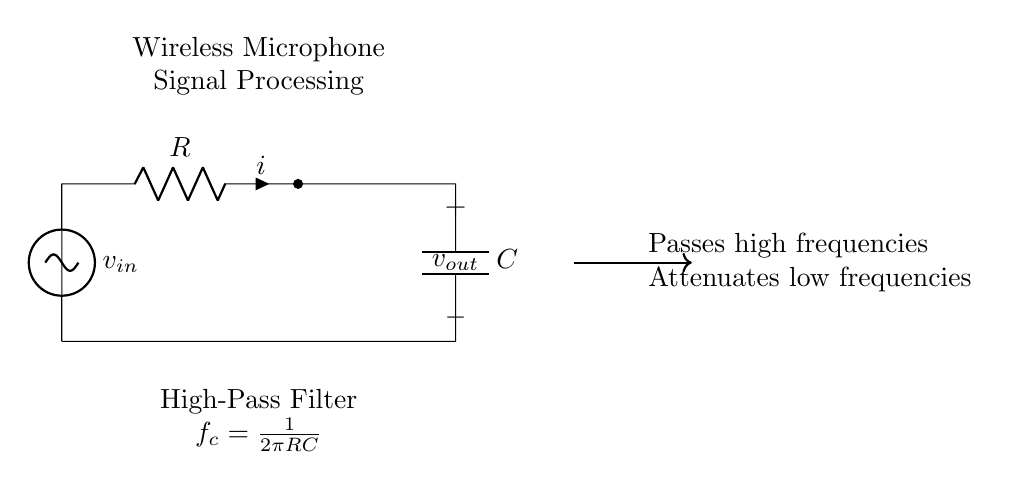What is the type of filter represented in this circuit? The circuit diagram depicts a high-pass filter, which is specifically engineered to allow high-frequency signals while blocking low-frequency signals. This is indicated by the components and the labeling in the diagram noting it as a high-pass filter.
Answer: high-pass filter What are the components used in the high-pass filter? The components in the circuit are a resistor and a capacitor. The resistor is denoted as "R," and the capacitor is denoted as "C." Their arrangement is characteristic of a high-pass filter.
Answer: resistor and capacitor What is the formula for the cutoff frequency? The cutoff frequency of the high-pass filter is calculated using the formula f_c = 1/(2πRC). This formula represents the frequency at which the output voltage falls to 70.7% of the input voltage.
Answer: 1/(2πRC) What does the high-pass filter do to low frequencies? This filter attenuates low frequencies, meaning it reduces their amplitude as they pass through the circuit. The diagram’s labeling indicates that it specifically targets low-frequency interference by minimizing its presence in the output.
Answer: attenuates What is the output voltage denoted as in the circuit? The output voltage is denoted as "v_out." In the circuit, it signifies the voltage that is available at the output terminals of the high-pass filter after processing the input signal.
Answer: v_out How does the high-pass filter affect the input signal? The high-pass filter modifies the input signal v_in by allowing high frequencies to pass through while reducing the strength of low-frequency signals. This function is vital in filtering out unwanted noise or interference in applications like wireless microphones.
Answer: passes high frequencies 